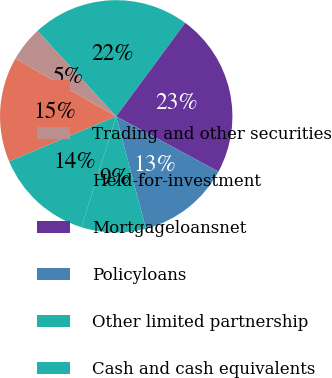Convert chart. <chart><loc_0><loc_0><loc_500><loc_500><pie_chart><ecel><fcel>Trading and other securities<fcel>Held-for-investment<fcel>Mortgageloansnet<fcel>Policyloans<fcel>Other limited partnership<fcel>Cash and cash equivalents<nl><fcel>14.63%<fcel>4.88%<fcel>21.95%<fcel>22.76%<fcel>13.01%<fcel>8.94%<fcel>13.82%<nl></chart> 